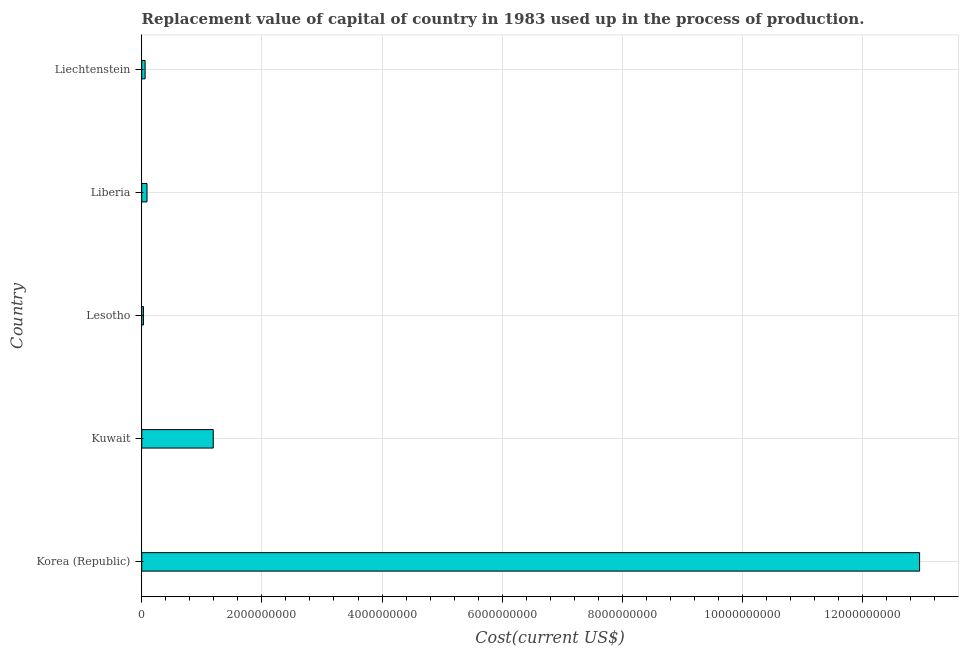Does the graph contain any zero values?
Offer a very short reply. No. What is the title of the graph?
Offer a very short reply. Replacement value of capital of country in 1983 used up in the process of production. What is the label or title of the X-axis?
Make the answer very short. Cost(current US$). What is the label or title of the Y-axis?
Provide a succinct answer. Country. What is the consumption of fixed capital in Liechtenstein?
Give a very brief answer. 5.63e+07. Across all countries, what is the maximum consumption of fixed capital?
Give a very brief answer. 1.29e+1. Across all countries, what is the minimum consumption of fixed capital?
Your answer should be very brief. 2.91e+07. In which country was the consumption of fixed capital maximum?
Ensure brevity in your answer.  Korea (Republic). In which country was the consumption of fixed capital minimum?
Your answer should be compact. Lesotho. What is the sum of the consumption of fixed capital?
Provide a short and direct response. 1.43e+1. What is the difference between the consumption of fixed capital in Liberia and Liechtenstein?
Provide a succinct answer. 3.15e+07. What is the average consumption of fixed capital per country?
Your response must be concise. 2.86e+09. What is the median consumption of fixed capital?
Provide a succinct answer. 8.78e+07. In how many countries, is the consumption of fixed capital greater than 7200000000 US$?
Offer a terse response. 1. What is the ratio of the consumption of fixed capital in Korea (Republic) to that in Kuwait?
Keep it short and to the point. 10.88. Is the difference between the consumption of fixed capital in Korea (Republic) and Liechtenstein greater than the difference between any two countries?
Give a very brief answer. No. What is the difference between the highest and the second highest consumption of fixed capital?
Your answer should be compact. 1.18e+1. Is the sum of the consumption of fixed capital in Korea (Republic) and Liechtenstein greater than the maximum consumption of fixed capital across all countries?
Give a very brief answer. Yes. What is the difference between the highest and the lowest consumption of fixed capital?
Your response must be concise. 1.29e+1. In how many countries, is the consumption of fixed capital greater than the average consumption of fixed capital taken over all countries?
Offer a terse response. 1. How many bars are there?
Your response must be concise. 5. What is the difference between two consecutive major ticks on the X-axis?
Make the answer very short. 2.00e+09. What is the Cost(current US$) of Korea (Republic)?
Offer a terse response. 1.29e+1. What is the Cost(current US$) of Kuwait?
Provide a short and direct response. 1.19e+09. What is the Cost(current US$) of Lesotho?
Keep it short and to the point. 2.91e+07. What is the Cost(current US$) of Liberia?
Keep it short and to the point. 8.78e+07. What is the Cost(current US$) in Liechtenstein?
Ensure brevity in your answer.  5.63e+07. What is the difference between the Cost(current US$) in Korea (Republic) and Kuwait?
Keep it short and to the point. 1.18e+1. What is the difference between the Cost(current US$) in Korea (Republic) and Lesotho?
Your answer should be compact. 1.29e+1. What is the difference between the Cost(current US$) in Korea (Republic) and Liberia?
Keep it short and to the point. 1.29e+1. What is the difference between the Cost(current US$) in Korea (Republic) and Liechtenstein?
Offer a very short reply. 1.29e+1. What is the difference between the Cost(current US$) in Kuwait and Lesotho?
Keep it short and to the point. 1.16e+09. What is the difference between the Cost(current US$) in Kuwait and Liberia?
Keep it short and to the point. 1.10e+09. What is the difference between the Cost(current US$) in Kuwait and Liechtenstein?
Your answer should be very brief. 1.13e+09. What is the difference between the Cost(current US$) in Lesotho and Liberia?
Keep it short and to the point. -5.87e+07. What is the difference between the Cost(current US$) in Lesotho and Liechtenstein?
Offer a terse response. -2.72e+07. What is the difference between the Cost(current US$) in Liberia and Liechtenstein?
Your answer should be very brief. 3.15e+07. What is the ratio of the Cost(current US$) in Korea (Republic) to that in Kuwait?
Your response must be concise. 10.88. What is the ratio of the Cost(current US$) in Korea (Republic) to that in Lesotho?
Give a very brief answer. 444.5. What is the ratio of the Cost(current US$) in Korea (Republic) to that in Liberia?
Your answer should be very brief. 147.42. What is the ratio of the Cost(current US$) in Korea (Republic) to that in Liechtenstein?
Provide a succinct answer. 229.8. What is the ratio of the Cost(current US$) in Kuwait to that in Lesotho?
Give a very brief answer. 40.87. What is the ratio of the Cost(current US$) in Kuwait to that in Liberia?
Ensure brevity in your answer.  13.56. What is the ratio of the Cost(current US$) in Kuwait to that in Liechtenstein?
Offer a terse response. 21.13. What is the ratio of the Cost(current US$) in Lesotho to that in Liberia?
Your answer should be very brief. 0.33. What is the ratio of the Cost(current US$) in Lesotho to that in Liechtenstein?
Provide a short and direct response. 0.52. What is the ratio of the Cost(current US$) in Liberia to that in Liechtenstein?
Provide a short and direct response. 1.56. 